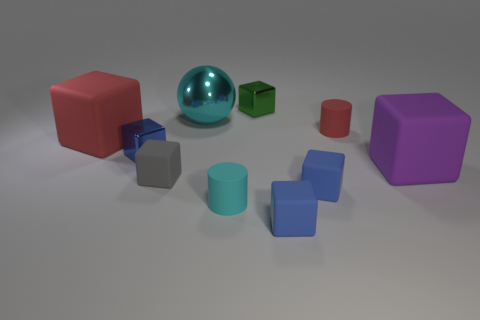What color is the matte object that is to the left of the big metal sphere and to the right of the large red matte cube?
Keep it short and to the point. Gray. There is a big purple object right of the cylinder to the left of the green metal thing; what is its material?
Provide a short and direct response. Rubber. Is the size of the metal sphere the same as the red matte block?
Your answer should be very brief. Yes. What number of tiny things are cyan metal things or matte objects?
Your answer should be very brief. 5. How many tiny blue rubber blocks are on the left side of the big shiny sphere?
Your response must be concise. 0. Are there more tiny blue metal blocks to the right of the small red rubber cylinder than tiny cyan matte objects?
Provide a succinct answer. No. What shape is the purple thing that is the same material as the gray block?
Provide a succinct answer. Cube. What color is the large matte thing on the right side of the big rubber block on the left side of the small blue shiny block?
Keep it short and to the point. Purple. Is the shape of the small green thing the same as the cyan shiny object?
Give a very brief answer. No. There is a tiny red object that is the same shape as the tiny cyan rubber object; what material is it?
Provide a succinct answer. Rubber. 